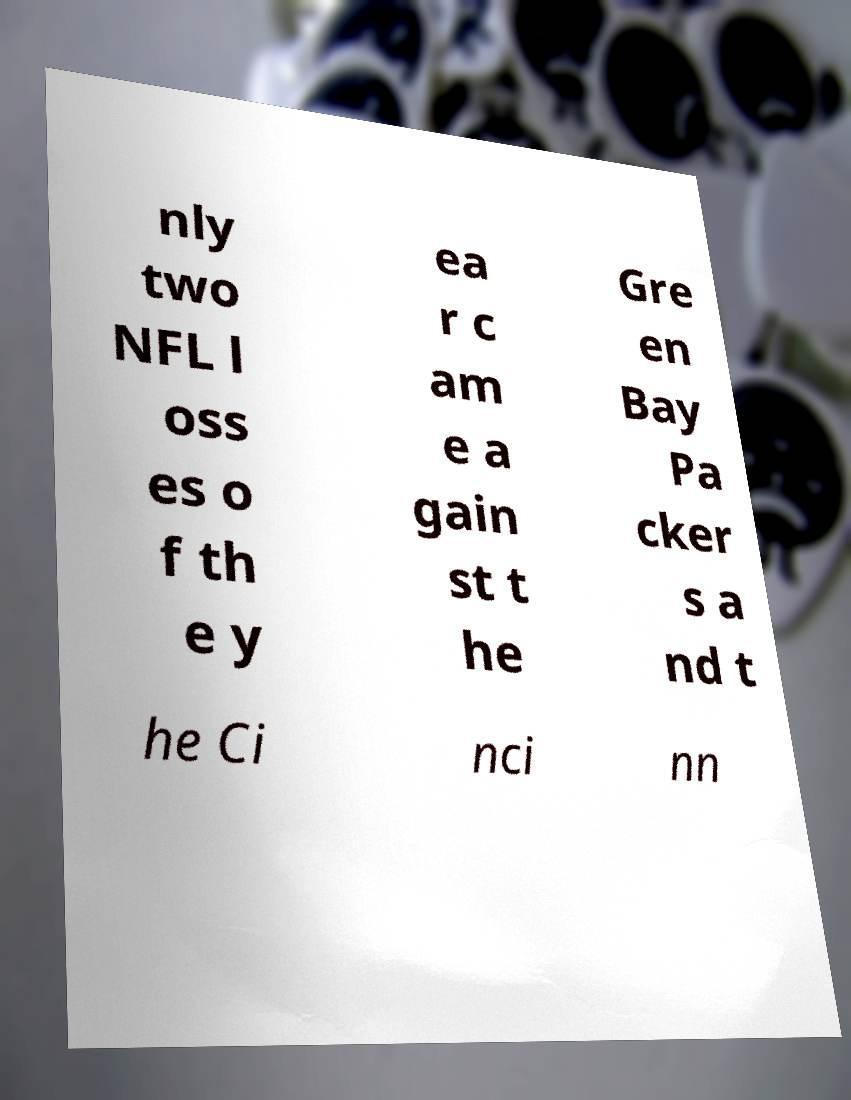Please identify and transcribe the text found in this image. nly two NFL l oss es o f th e y ea r c am e a gain st t he Gre en Bay Pa cker s a nd t he Ci nci nn 